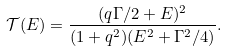Convert formula to latex. <formula><loc_0><loc_0><loc_500><loc_500>\mathcal { T } ( E ) = \frac { ( q \Gamma / 2 + E ) ^ { 2 } } { ( 1 + q ^ { 2 } ) ( E ^ { 2 } + \Gamma ^ { 2 } / 4 ) } .</formula> 